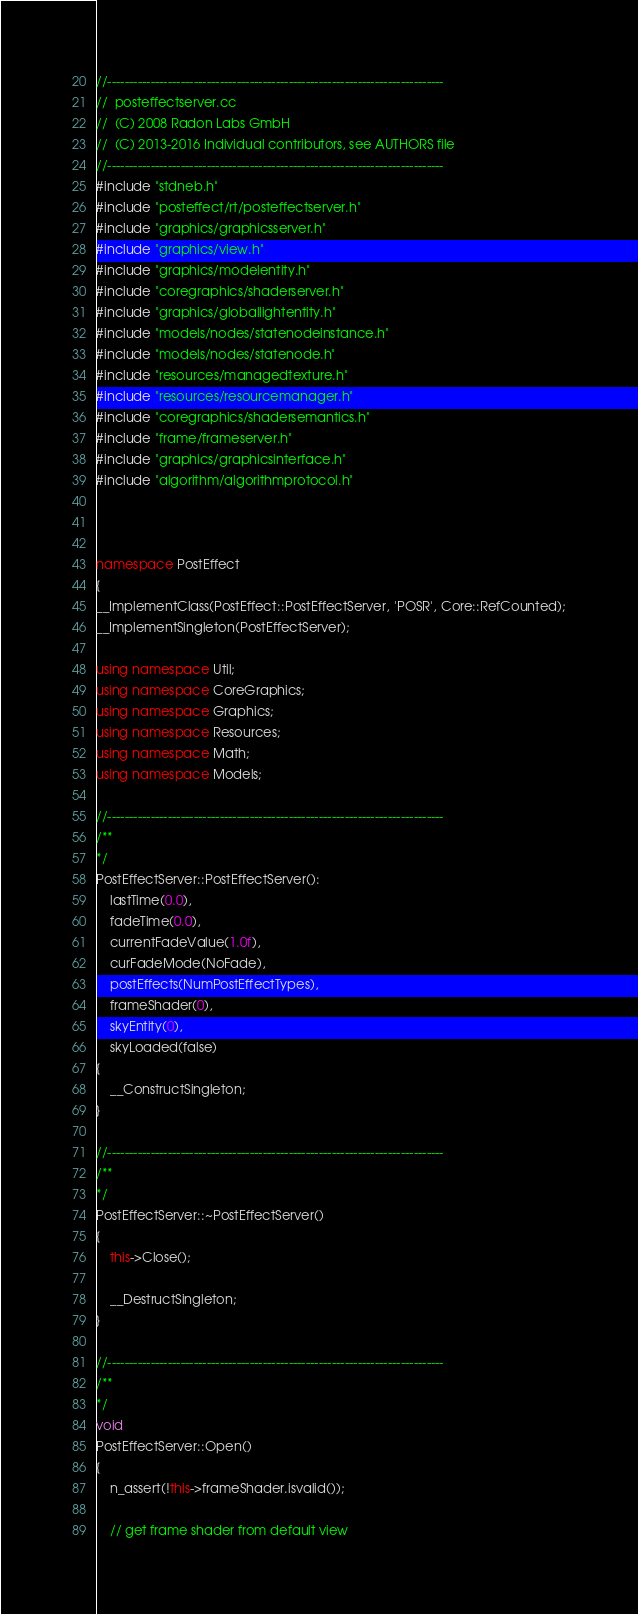<code> <loc_0><loc_0><loc_500><loc_500><_C++_>//------------------------------------------------------------------------------
//  posteffectserver.cc
//  (C) 2008 Radon Labs GmbH
//  (C) 2013-2016 Individual contributors, see AUTHORS file
//------------------------------------------------------------------------------
#include "stdneb.h"
#include "posteffect/rt/posteffectserver.h"
#include "graphics/graphicsserver.h"
#include "graphics/view.h"
#include "graphics/modelentity.h"
#include "coregraphics/shaderserver.h"
#include "graphics/globallightentity.h"
#include "models/nodes/statenodeinstance.h"
#include "models/nodes/statenode.h"
#include "resources/managedtexture.h"
#include "resources/resourcemanager.h"
#include "coregraphics/shadersemantics.h"
#include "frame/frameserver.h"
#include "graphics/graphicsinterface.h"
#include "algorithm/algorithmprotocol.h"



namespace PostEffect
{
__ImplementClass(PostEffect::PostEffectServer, 'POSR', Core::RefCounted);
__ImplementSingleton(PostEffectServer);

using namespace Util;
using namespace CoreGraphics;
using namespace Graphics;
using namespace Resources;
using namespace Math;
using namespace Models;

//------------------------------------------------------------------------------
/**
*/
PostEffectServer::PostEffectServer():
    lastTime(0.0),
    fadeTime(0.0),
    currentFadeValue(1.0f),
    curFadeMode(NoFade),
    postEffects(NumPostEffectTypes),
    frameShader(0),
	skyEntity(0),	
    skyLoaded(false)
{
    __ConstructSingleton;
}

//------------------------------------------------------------------------------
/**
*/
PostEffectServer::~PostEffectServer()
{
    this->Close();

    __DestructSingleton;
}

//------------------------------------------------------------------------------
/**
*/
void 
PostEffectServer::Open()
{
    n_assert(!this->frameShader.isvalid());

    // get frame shader from default view</code> 